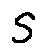<formula> <loc_0><loc_0><loc_500><loc_500>s</formula> 